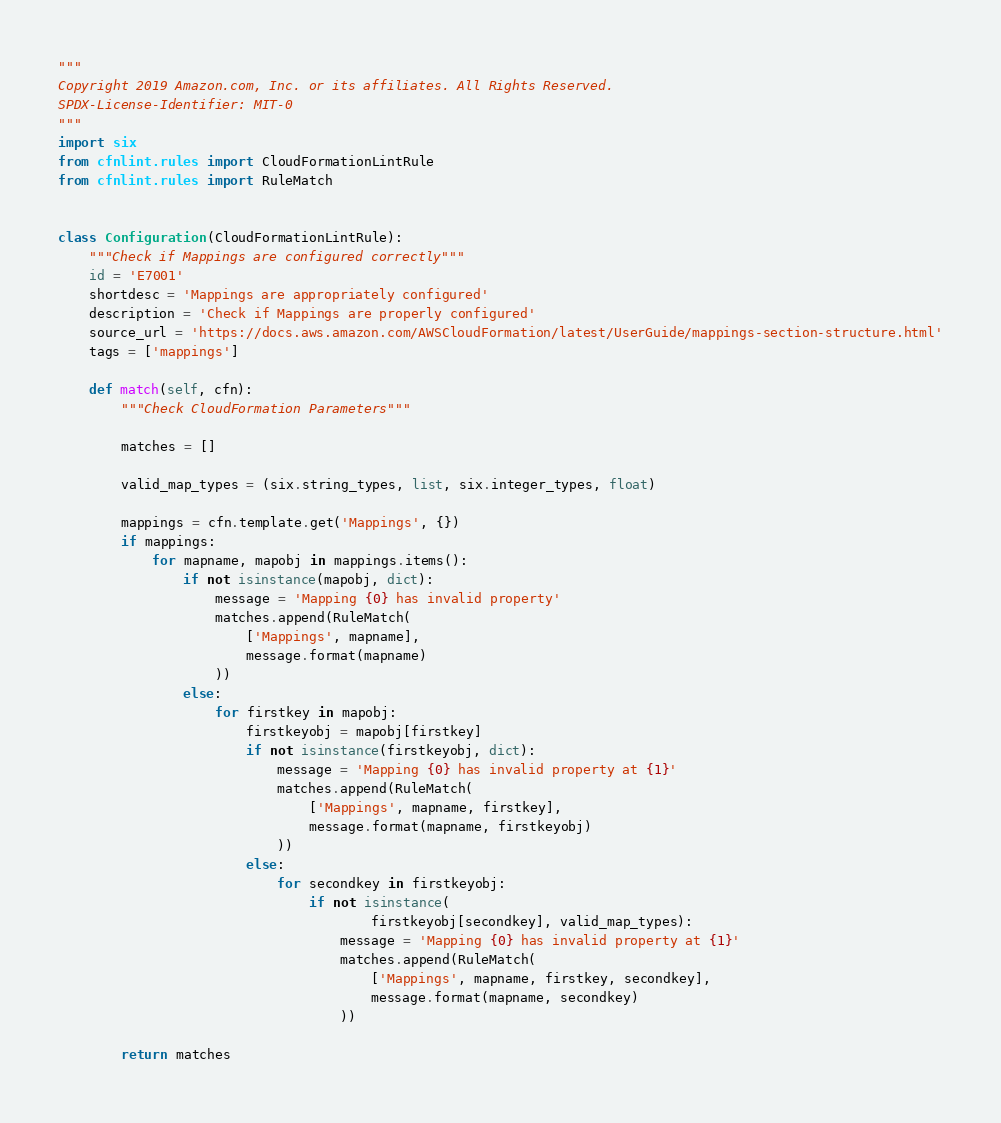<code> <loc_0><loc_0><loc_500><loc_500><_Python_>"""
Copyright 2019 Amazon.com, Inc. or its affiliates. All Rights Reserved.
SPDX-License-Identifier: MIT-0
"""
import six
from cfnlint.rules import CloudFormationLintRule
from cfnlint.rules import RuleMatch


class Configuration(CloudFormationLintRule):
    """Check if Mappings are configured correctly"""
    id = 'E7001'
    shortdesc = 'Mappings are appropriately configured'
    description = 'Check if Mappings are properly configured'
    source_url = 'https://docs.aws.amazon.com/AWSCloudFormation/latest/UserGuide/mappings-section-structure.html'
    tags = ['mappings']

    def match(self, cfn):
        """Check CloudFormation Parameters"""

        matches = []

        valid_map_types = (six.string_types, list, six.integer_types, float)

        mappings = cfn.template.get('Mappings', {})
        if mappings:
            for mapname, mapobj in mappings.items():
                if not isinstance(mapobj, dict):
                    message = 'Mapping {0} has invalid property'
                    matches.append(RuleMatch(
                        ['Mappings', mapname],
                        message.format(mapname)
                    ))
                else:
                    for firstkey in mapobj:
                        firstkeyobj = mapobj[firstkey]
                        if not isinstance(firstkeyobj, dict):
                            message = 'Mapping {0} has invalid property at {1}'
                            matches.append(RuleMatch(
                                ['Mappings', mapname, firstkey],
                                message.format(mapname, firstkeyobj)
                            ))
                        else:
                            for secondkey in firstkeyobj:
                                if not isinstance(
                                        firstkeyobj[secondkey], valid_map_types):
                                    message = 'Mapping {0} has invalid property at {1}'
                                    matches.append(RuleMatch(
                                        ['Mappings', mapname, firstkey, secondkey],
                                        message.format(mapname, secondkey)
                                    ))

        return matches
</code> 